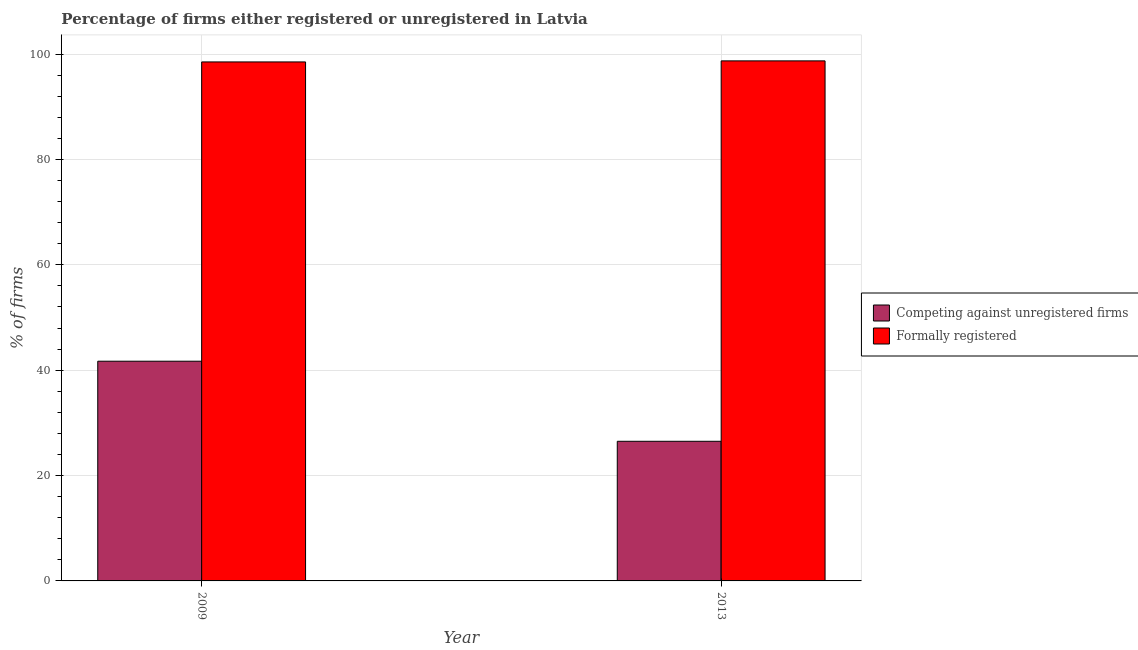How many different coloured bars are there?
Offer a very short reply. 2. Are the number of bars on each tick of the X-axis equal?
Offer a terse response. Yes. How many bars are there on the 1st tick from the right?
Offer a very short reply. 2. What is the percentage of formally registered firms in 2009?
Make the answer very short. 98.5. Across all years, what is the maximum percentage of formally registered firms?
Offer a terse response. 98.7. Across all years, what is the minimum percentage of formally registered firms?
Your answer should be compact. 98.5. In which year was the percentage of registered firms maximum?
Provide a short and direct response. 2009. What is the total percentage of formally registered firms in the graph?
Provide a short and direct response. 197.2. What is the difference between the percentage of registered firms in 2009 and that in 2013?
Give a very brief answer. 15.2. What is the difference between the percentage of formally registered firms in 2009 and the percentage of registered firms in 2013?
Your answer should be very brief. -0.2. What is the average percentage of registered firms per year?
Provide a succinct answer. 34.1. In how many years, is the percentage of registered firms greater than 80 %?
Keep it short and to the point. 0. What is the ratio of the percentage of registered firms in 2009 to that in 2013?
Your response must be concise. 1.57. In how many years, is the percentage of formally registered firms greater than the average percentage of formally registered firms taken over all years?
Offer a terse response. 1. What does the 2nd bar from the left in 2009 represents?
Give a very brief answer. Formally registered. What does the 1st bar from the right in 2009 represents?
Your answer should be compact. Formally registered. Are all the bars in the graph horizontal?
Keep it short and to the point. No. What is the difference between two consecutive major ticks on the Y-axis?
Your answer should be compact. 20. What is the title of the graph?
Offer a very short reply. Percentage of firms either registered or unregistered in Latvia. What is the label or title of the Y-axis?
Keep it short and to the point. % of firms. What is the % of firms of Competing against unregistered firms in 2009?
Offer a very short reply. 41.7. What is the % of firms of Formally registered in 2009?
Offer a very short reply. 98.5. What is the % of firms of Competing against unregistered firms in 2013?
Provide a short and direct response. 26.5. What is the % of firms of Formally registered in 2013?
Provide a succinct answer. 98.7. Across all years, what is the maximum % of firms in Competing against unregistered firms?
Offer a very short reply. 41.7. Across all years, what is the maximum % of firms of Formally registered?
Provide a short and direct response. 98.7. Across all years, what is the minimum % of firms of Competing against unregistered firms?
Offer a terse response. 26.5. Across all years, what is the minimum % of firms of Formally registered?
Provide a short and direct response. 98.5. What is the total % of firms in Competing against unregistered firms in the graph?
Offer a terse response. 68.2. What is the total % of firms of Formally registered in the graph?
Give a very brief answer. 197.2. What is the difference between the % of firms in Formally registered in 2009 and that in 2013?
Make the answer very short. -0.2. What is the difference between the % of firms of Competing against unregistered firms in 2009 and the % of firms of Formally registered in 2013?
Provide a succinct answer. -57. What is the average % of firms in Competing against unregistered firms per year?
Keep it short and to the point. 34.1. What is the average % of firms of Formally registered per year?
Offer a very short reply. 98.6. In the year 2009, what is the difference between the % of firms in Competing against unregistered firms and % of firms in Formally registered?
Your answer should be very brief. -56.8. In the year 2013, what is the difference between the % of firms of Competing against unregistered firms and % of firms of Formally registered?
Your response must be concise. -72.2. What is the ratio of the % of firms in Competing against unregistered firms in 2009 to that in 2013?
Ensure brevity in your answer.  1.57. What is the ratio of the % of firms in Formally registered in 2009 to that in 2013?
Offer a terse response. 1. What is the difference between the highest and the second highest % of firms in Competing against unregistered firms?
Make the answer very short. 15.2. What is the difference between the highest and the second highest % of firms in Formally registered?
Keep it short and to the point. 0.2. What is the difference between the highest and the lowest % of firms in Competing against unregistered firms?
Give a very brief answer. 15.2. What is the difference between the highest and the lowest % of firms of Formally registered?
Give a very brief answer. 0.2. 